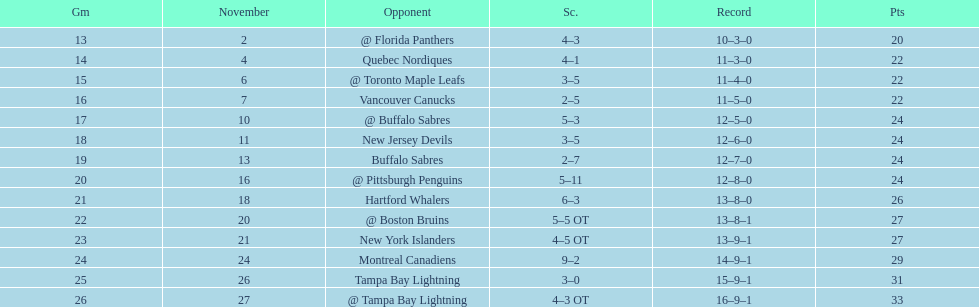The 1993-1994 flyers missed the playoffs again. how many consecutive seasons up until 93-94 did the flyers miss the playoffs? 5. Write the full table. {'header': ['Gm', 'November', 'Opponent', 'Sc.', 'Record', 'Pts'], 'rows': [['13', '2', '@ Florida Panthers', '4–3', '10–3–0', '20'], ['14', '4', 'Quebec Nordiques', '4–1', '11–3–0', '22'], ['15', '6', '@ Toronto Maple Leafs', '3–5', '11–4–0', '22'], ['16', '7', 'Vancouver Canucks', '2–5', '11–5–0', '22'], ['17', '10', '@ Buffalo Sabres', '5–3', '12–5–0', '24'], ['18', '11', 'New Jersey Devils', '3–5', '12–6–0', '24'], ['19', '13', 'Buffalo Sabres', '2–7', '12–7–0', '24'], ['20', '16', '@ Pittsburgh Penguins', '5–11', '12–8–0', '24'], ['21', '18', 'Hartford Whalers', '6–3', '13–8–0', '26'], ['22', '20', '@ Boston Bruins', '5–5 OT', '13–8–1', '27'], ['23', '21', 'New York Islanders', '4–5 OT', '13–9–1', '27'], ['24', '24', 'Montreal Canadiens', '9–2', '14–9–1', '29'], ['25', '26', 'Tampa Bay Lightning', '3–0', '15–9–1', '31'], ['26', '27', '@ Tampa Bay Lightning', '4–3 OT', '16–9–1', '33']]} 